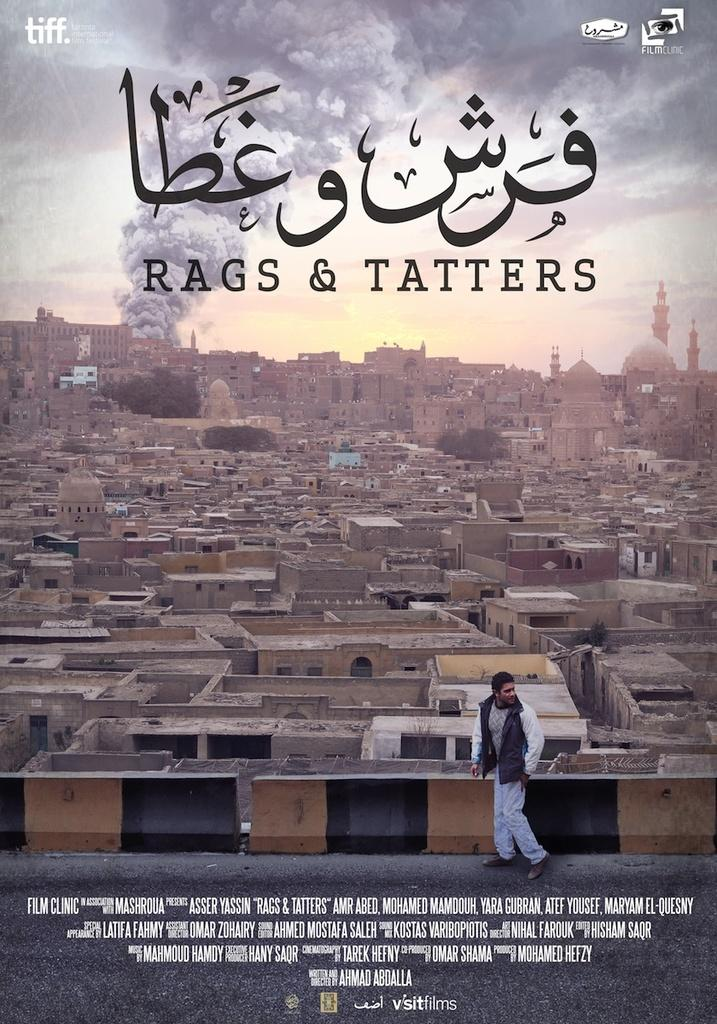<image>
Provide a brief description of the given image. The cover for a movie called Rags and Tatters. 